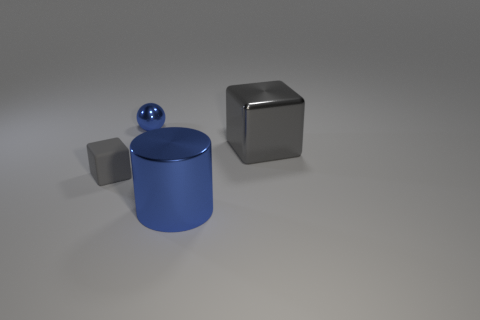Subtract all balls. How many objects are left? 3 Add 2 blue metallic objects. How many objects exist? 6 Subtract 1 cubes. How many cubes are left? 1 Subtract all big metal cubes. Subtract all small gray rubber cubes. How many objects are left? 2 Add 2 tiny gray blocks. How many tiny gray blocks are left? 3 Add 4 tiny cyan matte blocks. How many tiny cyan matte blocks exist? 4 Subtract 0 brown cylinders. How many objects are left? 4 Subtract all yellow cylinders. Subtract all blue balls. How many cylinders are left? 1 